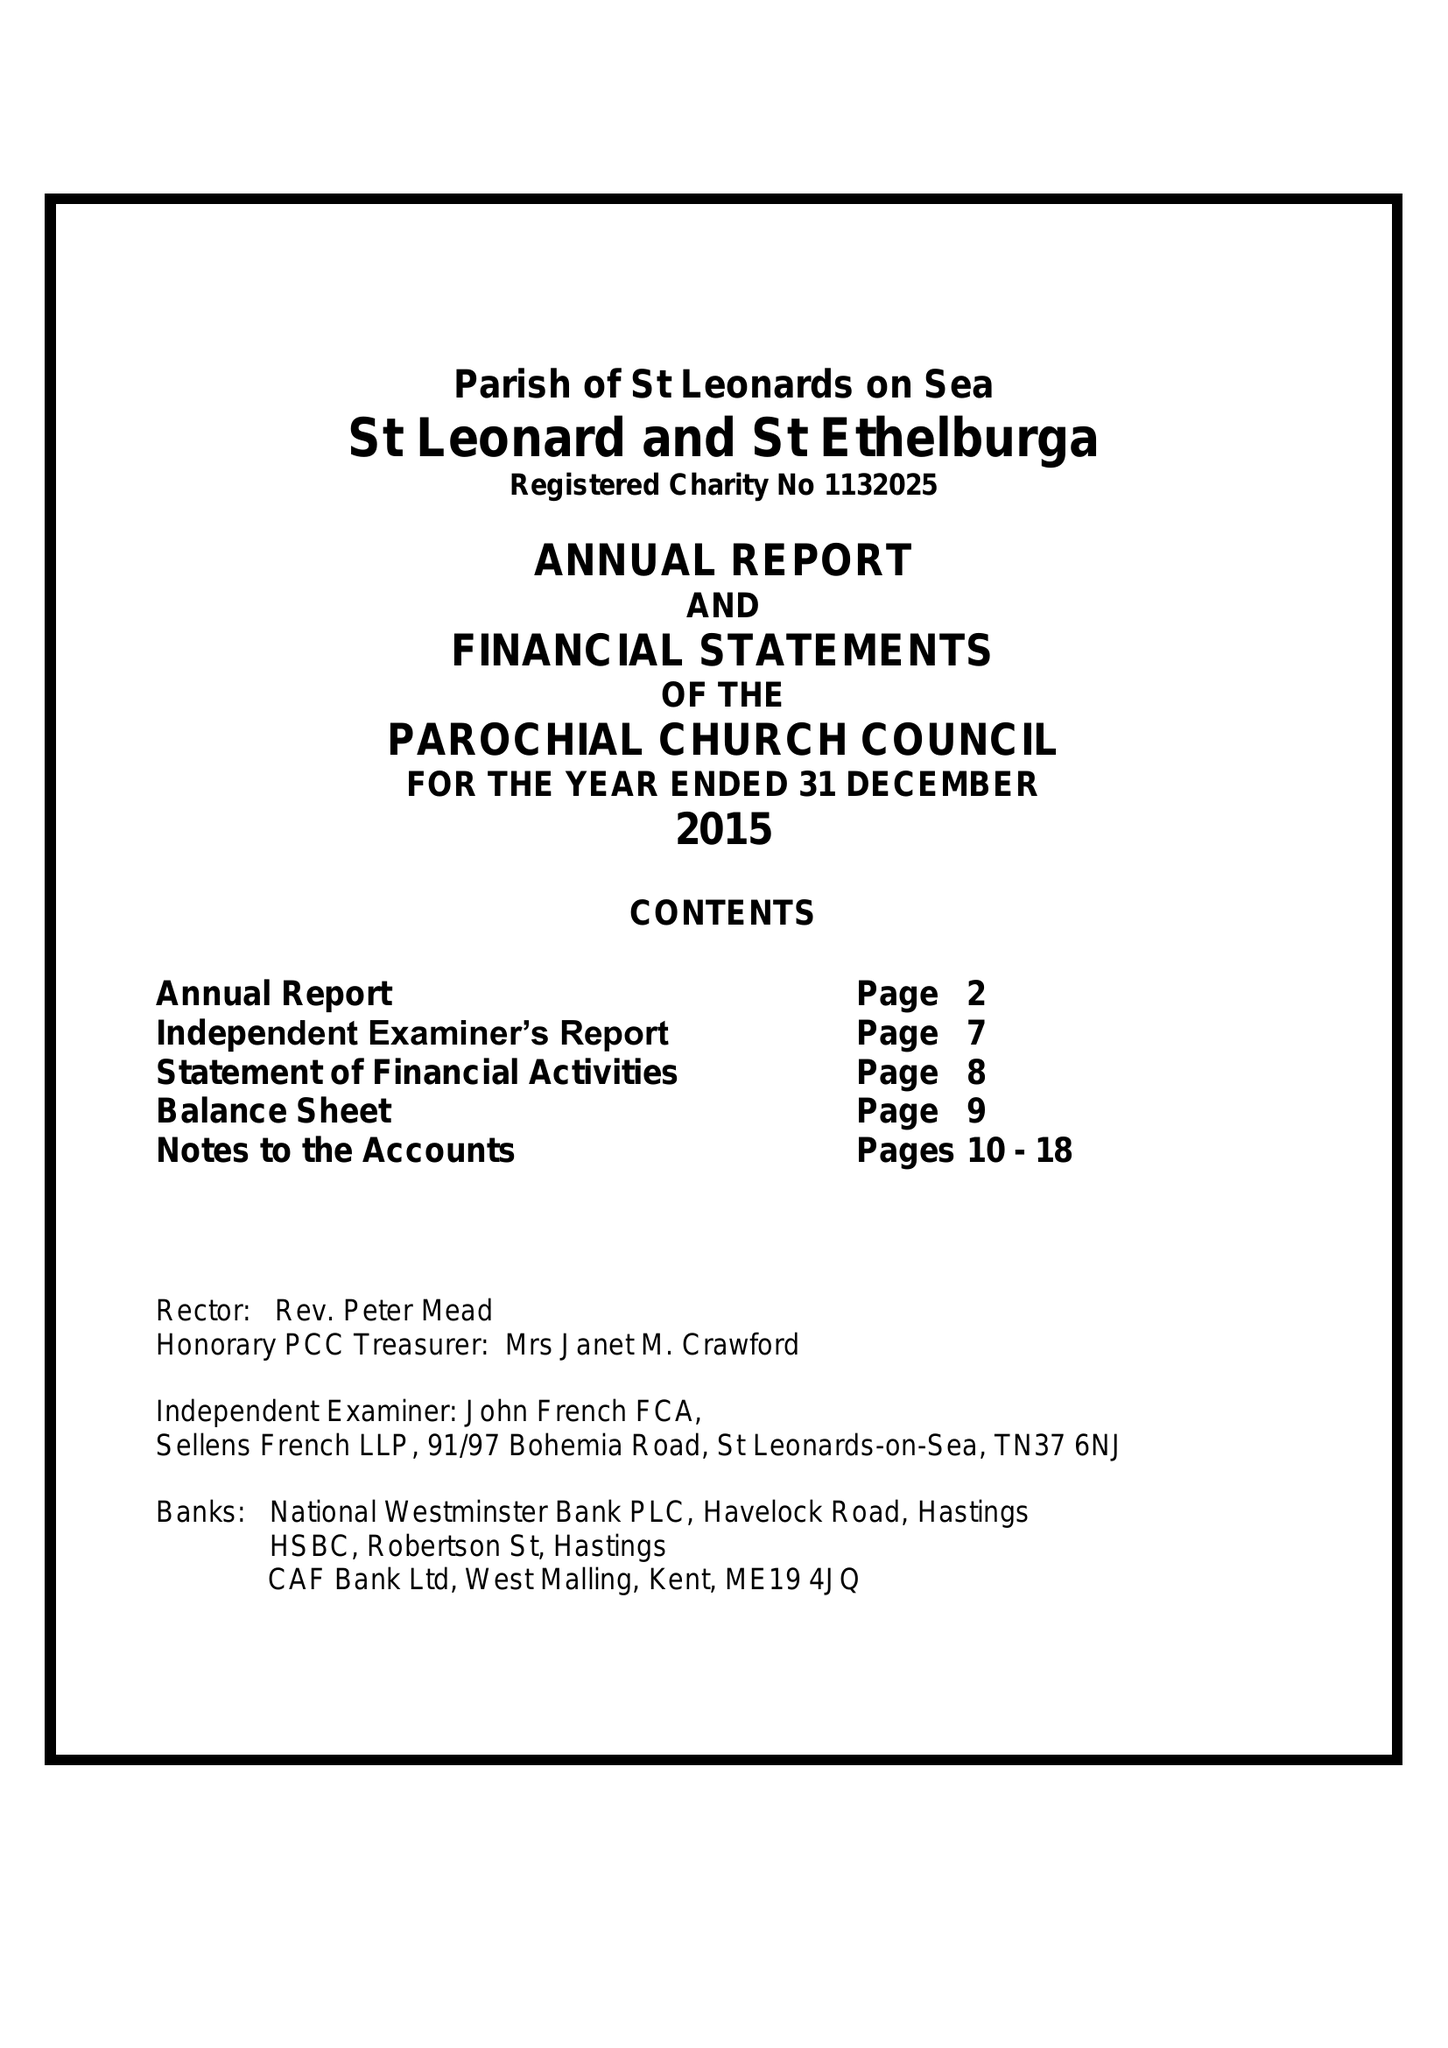What is the value for the income_annually_in_british_pounds?
Answer the question using a single word or phrase. 84222.00 